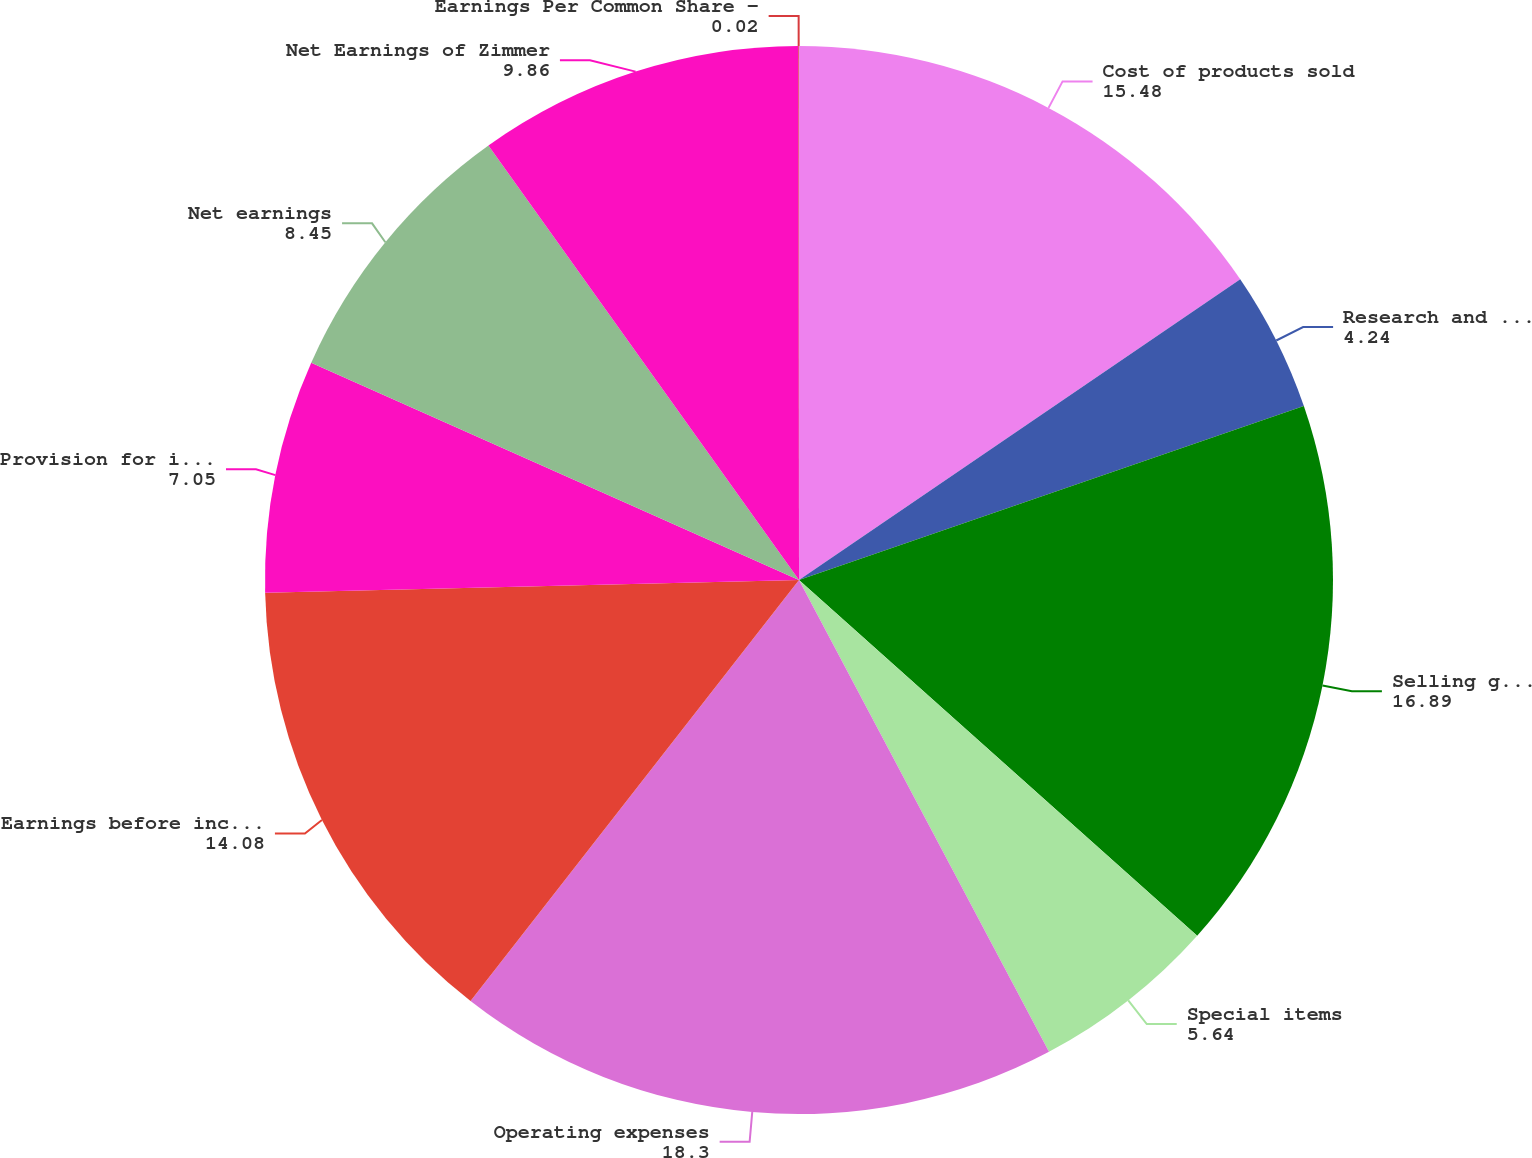Convert chart. <chart><loc_0><loc_0><loc_500><loc_500><pie_chart><fcel>Cost of products sold<fcel>Research and development<fcel>Selling general and<fcel>Special items<fcel>Operating expenses<fcel>Earnings before income taxes<fcel>Provision for income taxes<fcel>Net earnings<fcel>Net Earnings of Zimmer<fcel>Earnings Per Common Share -<nl><fcel>15.48%<fcel>4.24%<fcel>16.89%<fcel>5.64%<fcel>18.3%<fcel>14.08%<fcel>7.05%<fcel>8.45%<fcel>9.86%<fcel>0.02%<nl></chart> 